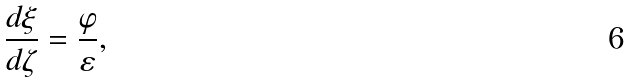<formula> <loc_0><loc_0><loc_500><loc_500>\frac { d \xi } { d \zeta } = \frac { \varphi } { \varepsilon } ,</formula> 